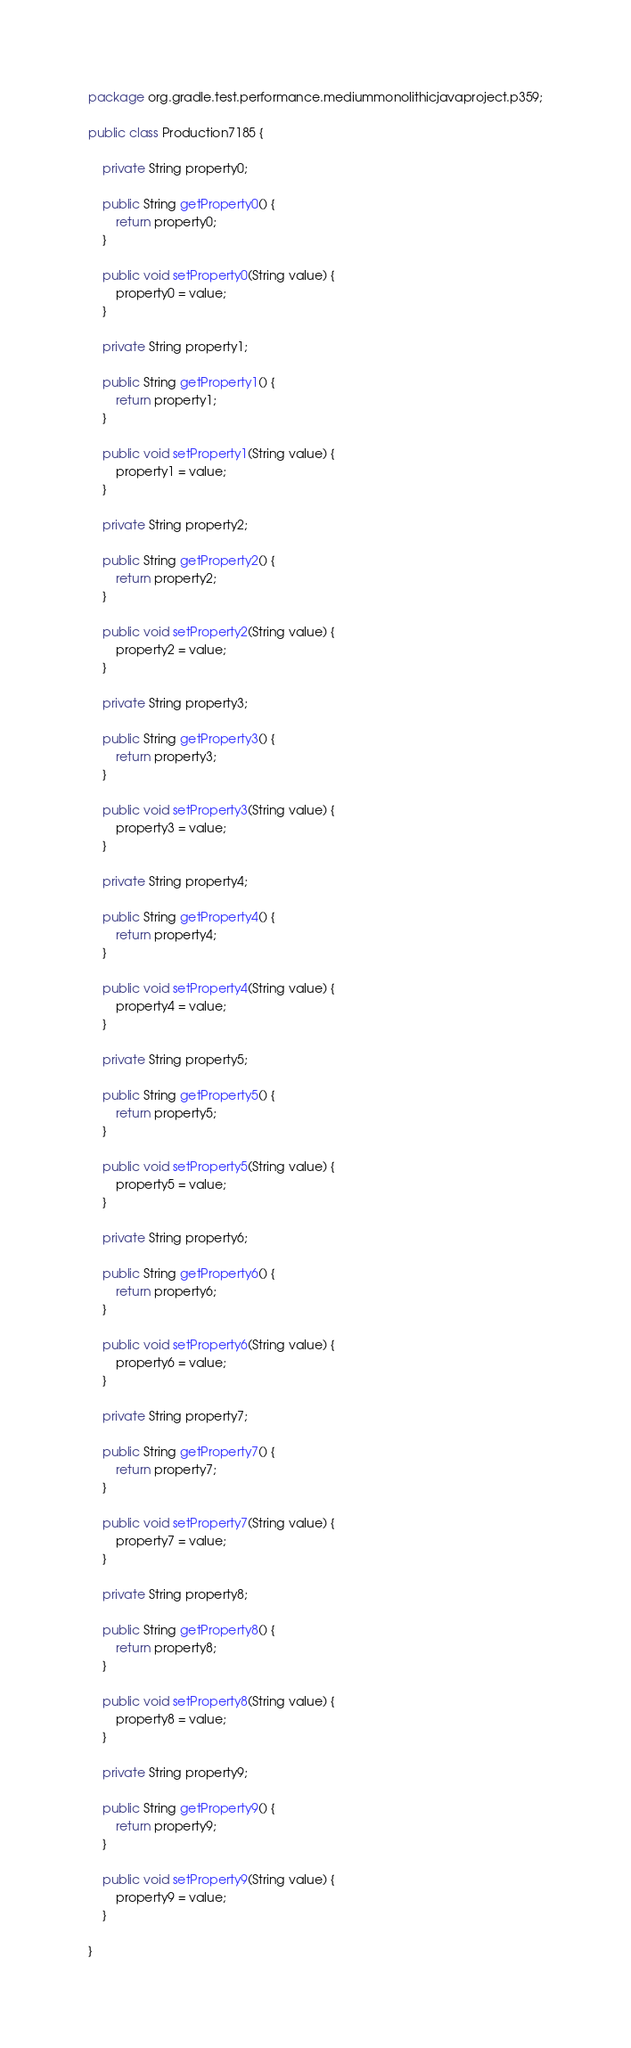<code> <loc_0><loc_0><loc_500><loc_500><_Java_>package org.gradle.test.performance.mediummonolithicjavaproject.p359;

public class Production7185 {        

    private String property0;

    public String getProperty0() {
        return property0;
    }

    public void setProperty0(String value) {
        property0 = value;
    }

    private String property1;

    public String getProperty1() {
        return property1;
    }

    public void setProperty1(String value) {
        property1 = value;
    }

    private String property2;

    public String getProperty2() {
        return property2;
    }

    public void setProperty2(String value) {
        property2 = value;
    }

    private String property3;

    public String getProperty3() {
        return property3;
    }

    public void setProperty3(String value) {
        property3 = value;
    }

    private String property4;

    public String getProperty4() {
        return property4;
    }

    public void setProperty4(String value) {
        property4 = value;
    }

    private String property5;

    public String getProperty5() {
        return property5;
    }

    public void setProperty5(String value) {
        property5 = value;
    }

    private String property6;

    public String getProperty6() {
        return property6;
    }

    public void setProperty6(String value) {
        property6 = value;
    }

    private String property7;

    public String getProperty7() {
        return property7;
    }

    public void setProperty7(String value) {
        property7 = value;
    }

    private String property8;

    public String getProperty8() {
        return property8;
    }

    public void setProperty8(String value) {
        property8 = value;
    }

    private String property9;

    public String getProperty9() {
        return property9;
    }

    public void setProperty9(String value) {
        property9 = value;
    }

}</code> 